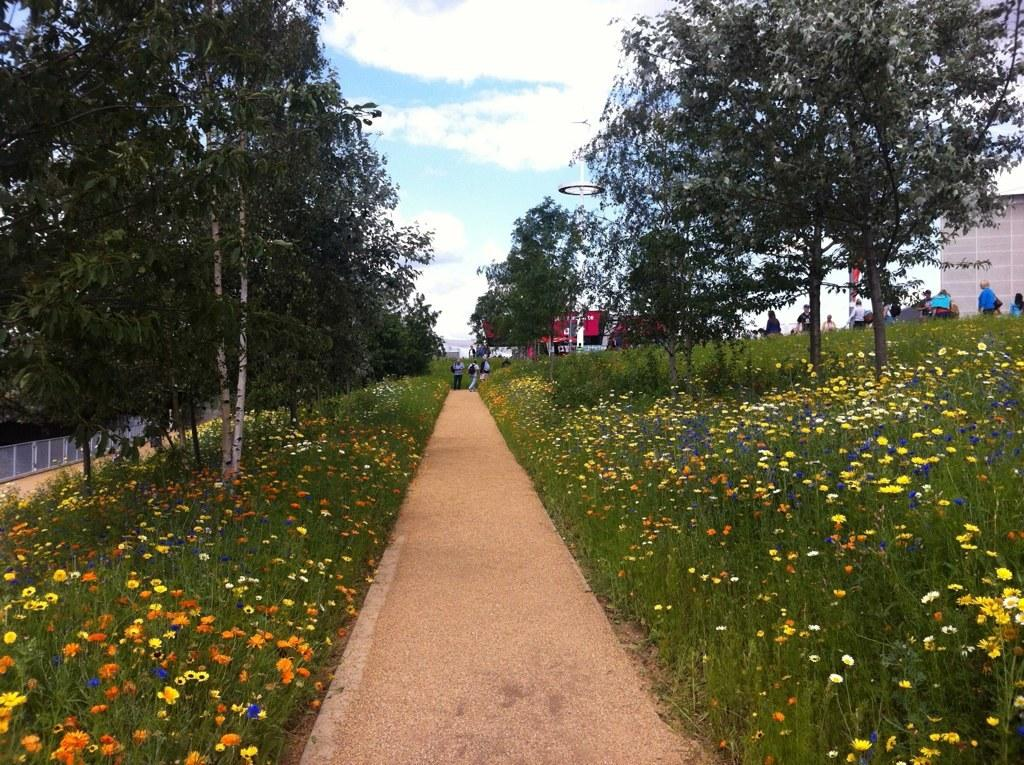What is the main feature in the middle of the image? There is a path in the middle of the image. What can be seen on either side of the path? Flower plants are present on either side of the path. What other natural elements are visible in the image? Trees are visible in the image. What is visible in the background of the image? The sky is visible in the image, and clouds are present in the sky. How does the guide use the feather to navigate the path in the image? There is no guide or feather present in the image; it features a path with flower plants on either side, trees, and a sky with clouds. 